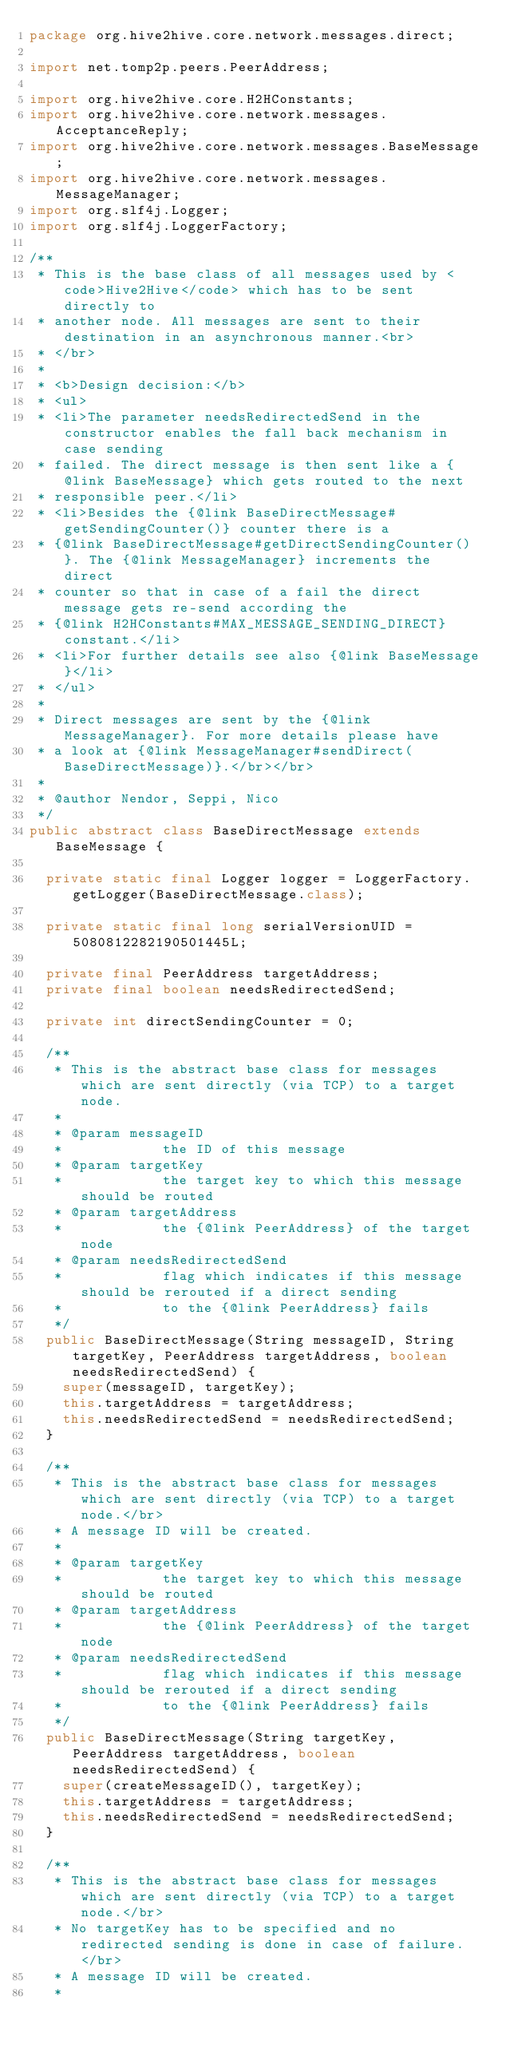Convert code to text. <code><loc_0><loc_0><loc_500><loc_500><_Java_>package org.hive2hive.core.network.messages.direct;

import net.tomp2p.peers.PeerAddress;

import org.hive2hive.core.H2HConstants;
import org.hive2hive.core.network.messages.AcceptanceReply;
import org.hive2hive.core.network.messages.BaseMessage;
import org.hive2hive.core.network.messages.MessageManager;
import org.slf4j.Logger;
import org.slf4j.LoggerFactory;

/**
 * This is the base class of all messages used by <code>Hive2Hive</code> which has to be sent directly to
 * another node. All messages are sent to their destination in an asynchronous manner.<br>
 * </br>
 * 
 * <b>Design decision:</b>
 * <ul>
 * <li>The parameter needsRedirectedSend in the constructor enables the fall back mechanism in case sending
 * failed. The direct message is then sent like a {@link BaseMessage} which gets routed to the next
 * responsible peer.</li>
 * <li>Besides the {@link BaseDirectMessage#getSendingCounter()} counter there is a
 * {@link BaseDirectMessage#getDirectSendingCounter()}. The {@link MessageManager} increments the direct
 * counter so that in case of a fail the direct message gets re-send according the
 * {@link H2HConstants#MAX_MESSAGE_SENDING_DIRECT} constant.</li>
 * <li>For further details see also {@link BaseMessage}</li>
 * </ul>
 * 
 * Direct messages are sent by the {@link MessageManager}. For more details please have
 * a look at {@link MessageManager#sendDirect(BaseDirectMessage)}.</br></br>
 * 
 * @author Nendor, Seppi, Nico
 */
public abstract class BaseDirectMessage extends BaseMessage {

	private static final Logger logger = LoggerFactory.getLogger(BaseDirectMessage.class);

	private static final long serialVersionUID = 5080812282190501445L;

	private final PeerAddress targetAddress;
	private final boolean needsRedirectedSend;

	private int directSendingCounter = 0;

	/**
	 * This is the abstract base class for messages which are sent directly (via TCP) to a target node.
	 * 
	 * @param messageID
	 *            the ID of this message
	 * @param targetKey
	 *            the target key to which this message should be routed
	 * @param targetAddress
	 *            the {@link PeerAddress} of the target node
	 * @param needsRedirectedSend
	 *            flag which indicates if this message should be rerouted if a direct sending
	 *            to the {@link PeerAddress} fails
	 */
	public BaseDirectMessage(String messageID, String targetKey, PeerAddress targetAddress, boolean needsRedirectedSend) {
		super(messageID, targetKey);
		this.targetAddress = targetAddress;
		this.needsRedirectedSend = needsRedirectedSend;
	}

	/**
	 * This is the abstract base class for messages which are sent directly (via TCP) to a target node.</br>
	 * A message ID will be created.
	 * 
	 * @param targetKey
	 *            the target key to which this message should be routed
	 * @param targetAddress
	 *            the {@link PeerAddress} of the target node
	 * @param needsRedirectedSend
	 *            flag which indicates if this message should be rerouted if a direct sending
	 *            to the {@link PeerAddress} fails
	 */
	public BaseDirectMessage(String targetKey, PeerAddress targetAddress, boolean needsRedirectedSend) {
		super(createMessageID(), targetKey);
		this.targetAddress = targetAddress;
		this.needsRedirectedSend = needsRedirectedSend;
	}

	/**
	 * This is the abstract base class for messages which are sent directly (via TCP) to a target node.</br>
	 * No targetKey has to be specified and no redirected sending is done in case of failure. </br>
	 * A message ID will be created.
	 * </code> 